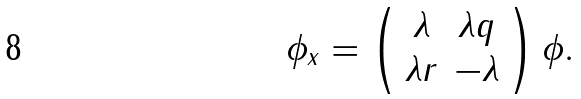Convert formula to latex. <formula><loc_0><loc_0><loc_500><loc_500>\phi _ { x } = \left ( \begin{array} { c c } \lambda & \lambda q \\ \lambda r & - \lambda \end{array} \right ) \phi .</formula> 